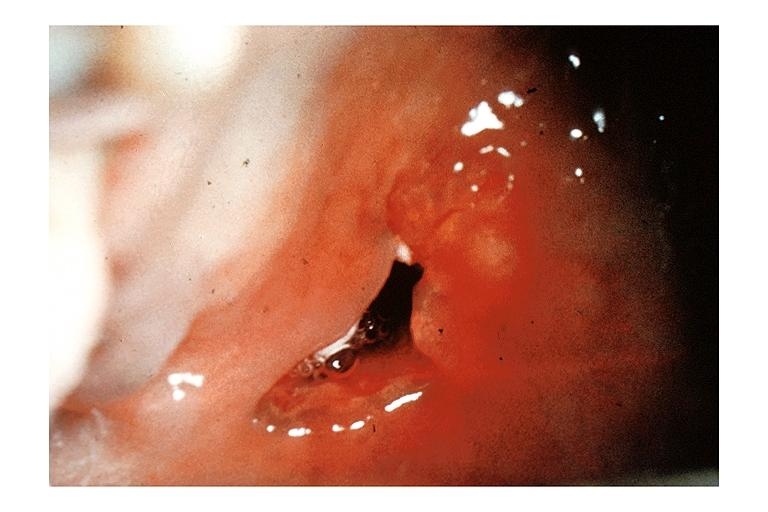does this image show mucoepidermoid carcinoma?
Answer the question using a single word or phrase. Yes 